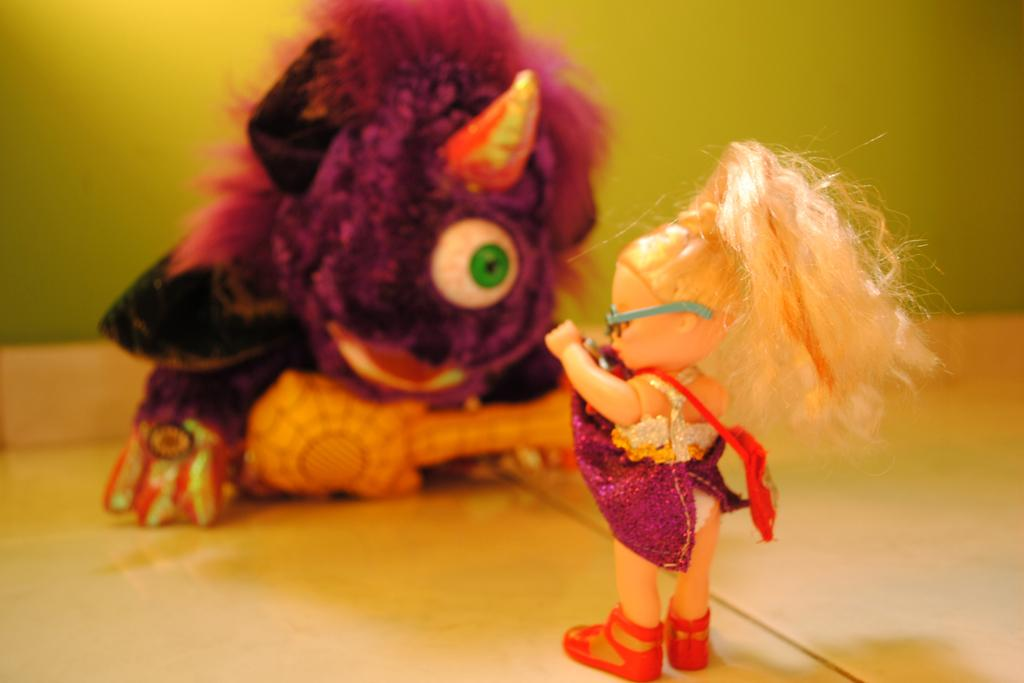What is the main subject in the foreground of the picture? There is a doll in the foreground of the picture. What other toy can be seen in the background? There is a monster face toy in the center of the background. Can you describe the background of the picture? The background is not clear. What type of wood can be seen in the bedroom in the image? There is no bedroom present in the image, and therefore no wood can be observed. 